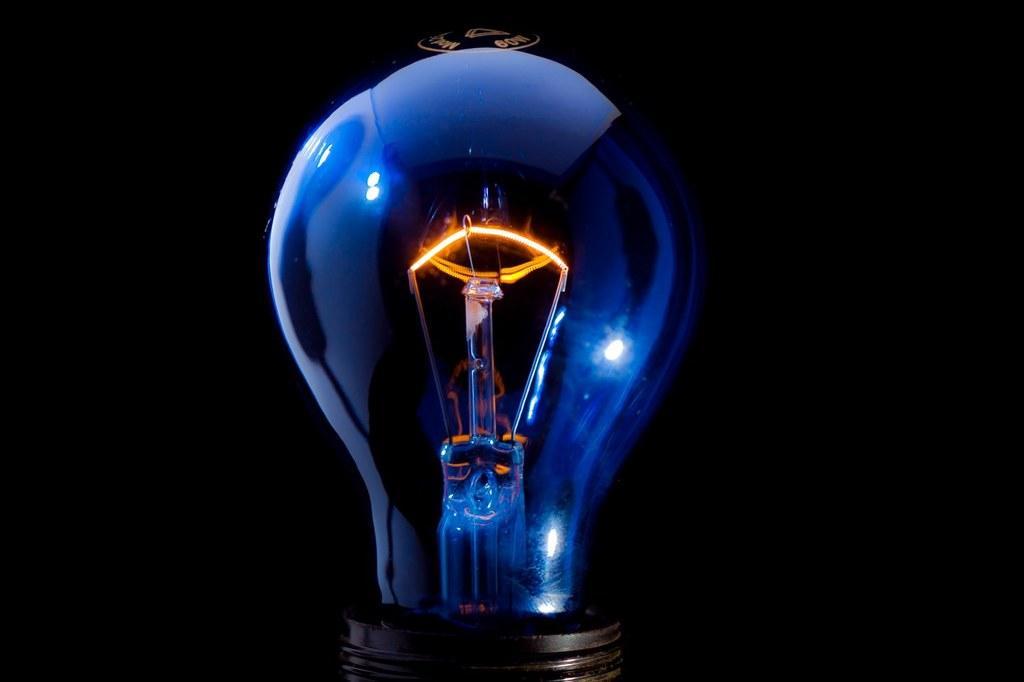Please provide a concise description of this image. This image consist of bulb which is in the center. 